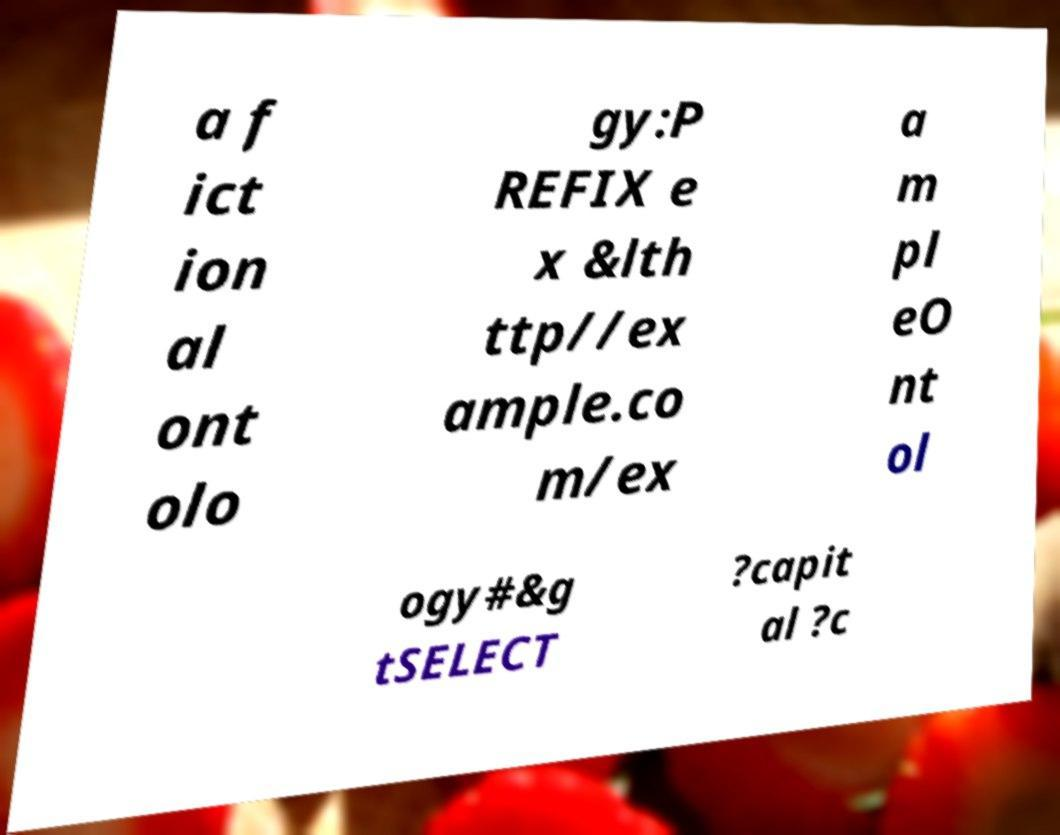Please read and relay the text visible in this image. What does it say? a f ict ion al ont olo gy:P REFIX e x &lth ttp//ex ample.co m/ex a m pl eO nt ol ogy#&g tSELECT ?capit al ?c 